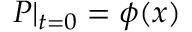<formula> <loc_0><loc_0><loc_500><loc_500>P | _ { t = 0 } = \phi ( x )</formula> 